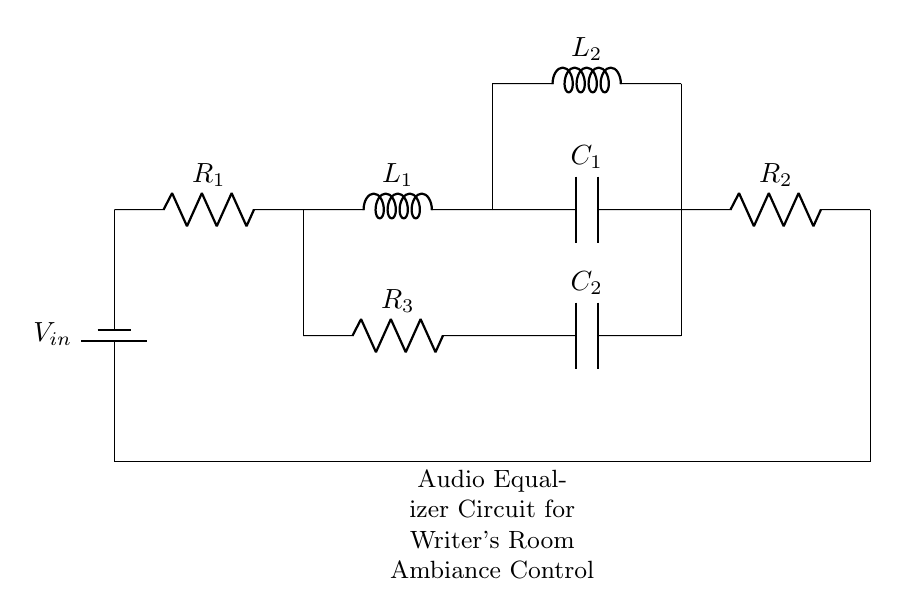What is the input voltage in this circuit? The input voltage, labeled as V_in in the circuit diagram, represents the source voltage provided to the circuit. It is typically the voltage supplied by a power source, such as a battery.
Answer: V_in How many resistors are present in the circuit? The circuit contains three resistors, which are labeled as R_1, R_2, and R_3. They are depicted in the diagram, showing their connections in the circuit.
Answer: Three What is the role of the inductor in this circuit? The inductor, labeled L_1 and L_2, in this circuit serves to store energy in a magnetic field when electrical current flows through it. It also reacts to changes in current, which can affect the overall impedance of the circuit.
Answer: Energy storage What is the function of the capacitor in this circuit? The capacitor, labeled C_1 and C_2, in this circuit is used to store energy in an electric field. It can also filter out high-frequency signals, playing a key role in shaping the audio characteristics of the circuit for ambiance adjustment.
Answer: Filtering What happens if R_1 is increased? Increasing R_1 would result in a higher resistance in series, reducing the overall current flowing through the circuit according to Ohm's Law (I = V/R). This would alter the voltage drop across other components, affecting the overall performance of the audio equalizer.
Answer: Decreased current How does the combination of R, L, and C affect the frequency response? The combination of resistors, inductors, and capacitors creates a reactive circuit that can either amplify or attenuate specific frequencies. The resonance created by L and C determines the circuit's behavior at certain frequencies, shaping the audio signal for specific ambient control requirements.
Answer: Frequency shaping 